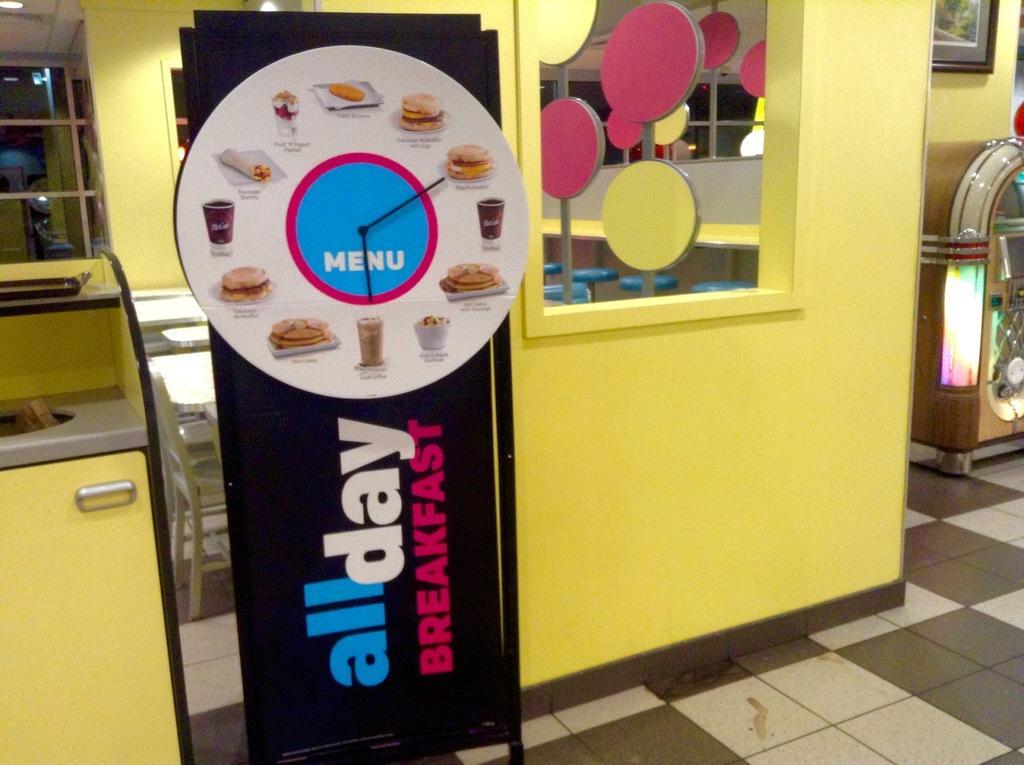Could you give a brief overview of what you see in this image? We can see board with pointers and banner with stand, beside this banner we can see cupboard and object on the surface. In the background we can see wall, glass, lights, tables, chairs and plain boards on poles. On the right side of the image we can see frame on a wall and object. 